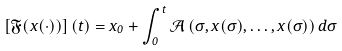Convert formula to latex. <formula><loc_0><loc_0><loc_500><loc_500>\left [ \mathfrak { F } ( x ( \cdot ) ) \right ] ( t ) = x _ { 0 } + \int _ { 0 } ^ { t } \mathcal { A } \left ( \sigma , x ( \sigma ) , \dots , x ( \sigma ) \right ) d \sigma</formula> 